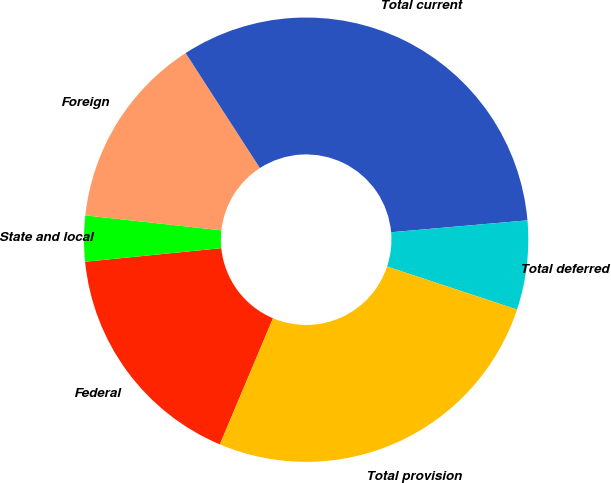Convert chart. <chart><loc_0><loc_0><loc_500><loc_500><pie_chart><fcel>Federal<fcel>State and local<fcel>Foreign<fcel>Total current<fcel>Total deferred<fcel>Total provision<nl><fcel>17.07%<fcel>3.33%<fcel>14.13%<fcel>32.74%<fcel>6.48%<fcel>26.26%<nl></chart> 